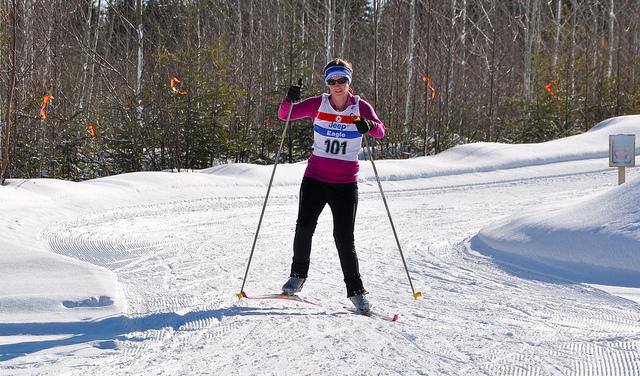Should she wear sunblock?
Keep it brief. Yes. Is the skier in a competition?
Be succinct. Yes. What number is this woman in the ski race?
Concise answer only. 101. 